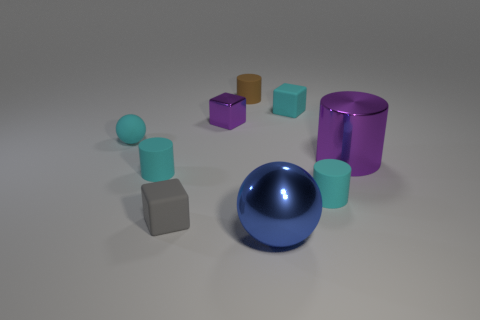What number of small things are red metal cylinders or brown cylinders?
Your response must be concise. 1. Are there an equal number of tiny purple metal things to the right of the large blue thing and purple rubber cylinders?
Make the answer very short. Yes. There is a block that is right of the small purple cube; is there a tiny purple metallic block to the left of it?
Offer a very short reply. Yes. How many other objects are there of the same color as the large cylinder?
Keep it short and to the point. 1. The large metallic cylinder has what color?
Provide a succinct answer. Purple. What size is the metal object that is behind the small gray matte cube and right of the tiny metallic object?
Your response must be concise. Large. How many things are either small cyan rubber things to the right of the cyan cube or rubber things?
Your response must be concise. 6. What is the shape of the other big thing that is made of the same material as the blue object?
Keep it short and to the point. Cylinder. What is the shape of the small metallic object?
Your answer should be very brief. Cube. What color is the matte object that is both behind the cyan rubber sphere and on the right side of the large blue metallic thing?
Make the answer very short. Cyan. 